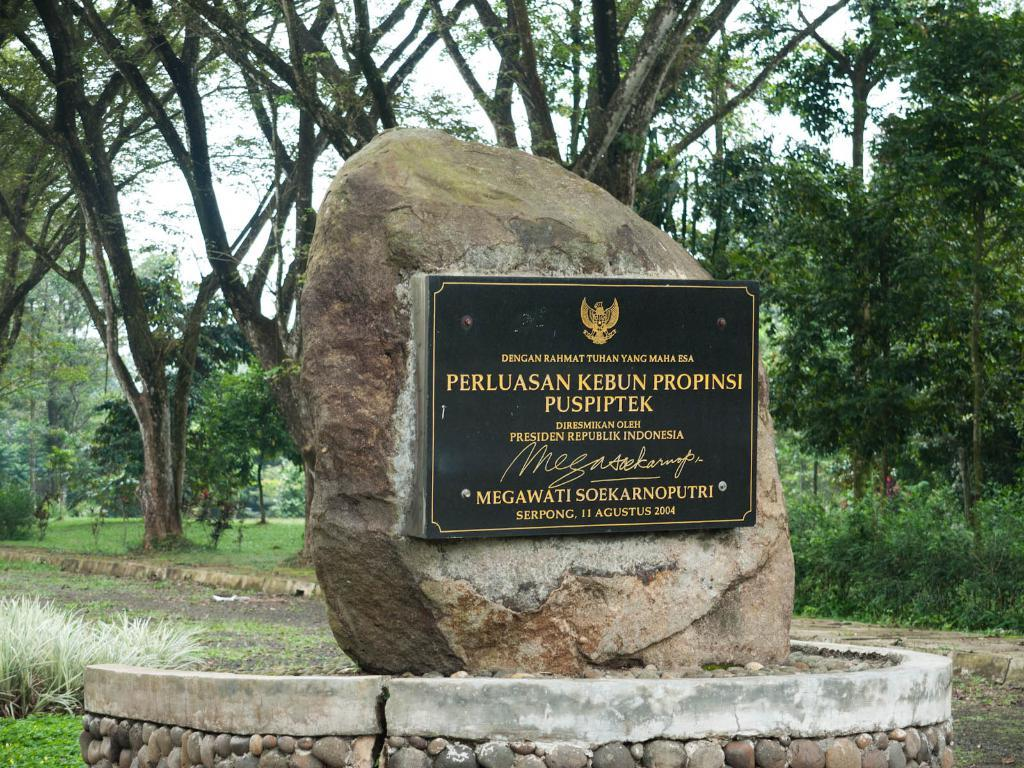What is the main object in the image? There is a board in the image. What is the board placed on? The board is on a stone. How is the board decorated or designed? The board is carved. What can be seen in the background of the image? There are trees behind the stone in the image. What type of noise can be heard coming from the vest in the image? There is no vest present in the image, so it is not possible to determine what type of noise might be heard. 